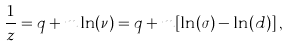<formula> <loc_0><loc_0><loc_500><loc_500>\frac { 1 } { z } = q + m \ln ( \nu ) = q + m [ \ln ( \sigma ) - \ln ( d ) ] \, ,</formula> 